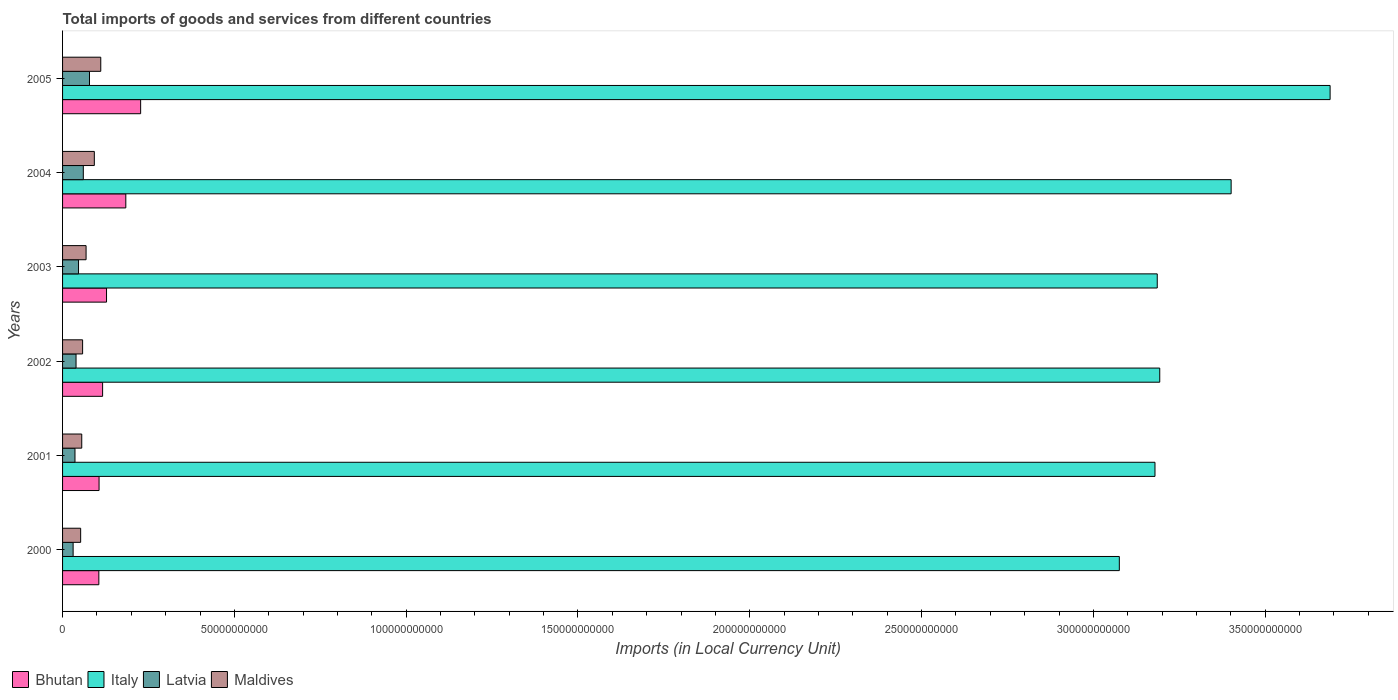How many different coloured bars are there?
Provide a short and direct response. 4. How many groups of bars are there?
Make the answer very short. 6. Are the number of bars on each tick of the Y-axis equal?
Your response must be concise. Yes. How many bars are there on the 2nd tick from the top?
Offer a very short reply. 4. What is the label of the 1st group of bars from the top?
Ensure brevity in your answer.  2005. In how many cases, is the number of bars for a given year not equal to the number of legend labels?
Provide a short and direct response. 0. What is the Amount of goods and services imports in Italy in 2001?
Provide a short and direct response. 3.18e+11. Across all years, what is the maximum Amount of goods and services imports in Maldives?
Keep it short and to the point. 1.11e+1. Across all years, what is the minimum Amount of goods and services imports in Bhutan?
Ensure brevity in your answer.  1.06e+1. What is the total Amount of goods and services imports in Latvia in the graph?
Your answer should be compact. 2.91e+1. What is the difference between the Amount of goods and services imports in Maldives in 2001 and that in 2003?
Your answer should be compact. -1.26e+09. What is the difference between the Amount of goods and services imports in Latvia in 2001 and the Amount of goods and services imports in Maldives in 2003?
Provide a succinct answer. -3.23e+09. What is the average Amount of goods and services imports in Bhutan per year?
Your answer should be compact. 1.45e+1. In the year 2003, what is the difference between the Amount of goods and services imports in Maldives and Amount of goods and services imports in Latvia?
Give a very brief answer. 2.19e+09. What is the ratio of the Amount of goods and services imports in Bhutan in 2003 to that in 2004?
Provide a short and direct response. 0.7. Is the Amount of goods and services imports in Maldives in 2002 less than that in 2005?
Your answer should be compact. Yes. What is the difference between the highest and the second highest Amount of goods and services imports in Bhutan?
Provide a succinct answer. 4.32e+09. What is the difference between the highest and the lowest Amount of goods and services imports in Bhutan?
Make the answer very short. 1.22e+1. Is the sum of the Amount of goods and services imports in Bhutan in 2002 and 2003 greater than the maximum Amount of goods and services imports in Maldives across all years?
Give a very brief answer. Yes. Is it the case that in every year, the sum of the Amount of goods and services imports in Bhutan and Amount of goods and services imports in Latvia is greater than the sum of Amount of goods and services imports in Maldives and Amount of goods and services imports in Italy?
Provide a succinct answer. Yes. What does the 3rd bar from the top in 2005 represents?
Ensure brevity in your answer.  Italy. What does the 2nd bar from the bottom in 2005 represents?
Provide a short and direct response. Italy. How many bars are there?
Provide a succinct answer. 24. How many years are there in the graph?
Keep it short and to the point. 6. What is the difference between two consecutive major ticks on the X-axis?
Your response must be concise. 5.00e+1. Are the values on the major ticks of X-axis written in scientific E-notation?
Your answer should be compact. No. Does the graph contain any zero values?
Offer a terse response. No. Does the graph contain grids?
Your answer should be compact. No. Where does the legend appear in the graph?
Provide a short and direct response. Bottom left. How many legend labels are there?
Give a very brief answer. 4. What is the title of the graph?
Your response must be concise. Total imports of goods and services from different countries. What is the label or title of the X-axis?
Ensure brevity in your answer.  Imports (in Local Currency Unit). What is the label or title of the Y-axis?
Provide a short and direct response. Years. What is the Imports (in Local Currency Unit) in Bhutan in 2000?
Your answer should be compact. 1.06e+1. What is the Imports (in Local Currency Unit) of Italy in 2000?
Offer a very short reply. 3.08e+11. What is the Imports (in Local Currency Unit) in Latvia in 2000?
Make the answer very short. 3.07e+09. What is the Imports (in Local Currency Unit) in Maldives in 2000?
Give a very brief answer. 5.26e+09. What is the Imports (in Local Currency Unit) of Bhutan in 2001?
Your response must be concise. 1.06e+1. What is the Imports (in Local Currency Unit) of Italy in 2001?
Provide a short and direct response. 3.18e+11. What is the Imports (in Local Currency Unit) in Latvia in 2001?
Your answer should be very brief. 3.61e+09. What is the Imports (in Local Currency Unit) of Maldives in 2001?
Provide a succinct answer. 5.58e+09. What is the Imports (in Local Currency Unit) in Bhutan in 2002?
Offer a terse response. 1.17e+1. What is the Imports (in Local Currency Unit) of Italy in 2002?
Provide a short and direct response. 3.19e+11. What is the Imports (in Local Currency Unit) in Latvia in 2002?
Your answer should be compact. 3.92e+09. What is the Imports (in Local Currency Unit) of Maldives in 2002?
Give a very brief answer. 5.84e+09. What is the Imports (in Local Currency Unit) in Bhutan in 2003?
Your response must be concise. 1.28e+1. What is the Imports (in Local Currency Unit) of Italy in 2003?
Your response must be concise. 3.19e+11. What is the Imports (in Local Currency Unit) of Latvia in 2003?
Provide a short and direct response. 4.65e+09. What is the Imports (in Local Currency Unit) in Maldives in 2003?
Provide a short and direct response. 6.84e+09. What is the Imports (in Local Currency Unit) of Bhutan in 2004?
Your answer should be compact. 1.84e+1. What is the Imports (in Local Currency Unit) in Italy in 2004?
Keep it short and to the point. 3.40e+11. What is the Imports (in Local Currency Unit) in Latvia in 2004?
Your answer should be very brief. 6.04e+09. What is the Imports (in Local Currency Unit) in Maldives in 2004?
Provide a succinct answer. 9.24e+09. What is the Imports (in Local Currency Unit) of Bhutan in 2005?
Offer a terse response. 2.27e+1. What is the Imports (in Local Currency Unit) in Italy in 2005?
Offer a very short reply. 3.69e+11. What is the Imports (in Local Currency Unit) in Latvia in 2005?
Your response must be concise. 7.84e+09. What is the Imports (in Local Currency Unit) of Maldives in 2005?
Provide a short and direct response. 1.11e+1. Across all years, what is the maximum Imports (in Local Currency Unit) of Bhutan?
Offer a very short reply. 2.27e+1. Across all years, what is the maximum Imports (in Local Currency Unit) in Italy?
Offer a very short reply. 3.69e+11. Across all years, what is the maximum Imports (in Local Currency Unit) in Latvia?
Keep it short and to the point. 7.84e+09. Across all years, what is the maximum Imports (in Local Currency Unit) in Maldives?
Make the answer very short. 1.11e+1. Across all years, what is the minimum Imports (in Local Currency Unit) in Bhutan?
Keep it short and to the point. 1.06e+1. Across all years, what is the minimum Imports (in Local Currency Unit) in Italy?
Keep it short and to the point. 3.08e+11. Across all years, what is the minimum Imports (in Local Currency Unit) of Latvia?
Your answer should be very brief. 3.07e+09. Across all years, what is the minimum Imports (in Local Currency Unit) in Maldives?
Your answer should be very brief. 5.26e+09. What is the total Imports (in Local Currency Unit) in Bhutan in the graph?
Ensure brevity in your answer.  8.68e+1. What is the total Imports (in Local Currency Unit) of Italy in the graph?
Your answer should be very brief. 1.97e+12. What is the total Imports (in Local Currency Unit) of Latvia in the graph?
Provide a succinct answer. 2.91e+1. What is the total Imports (in Local Currency Unit) in Maldives in the graph?
Your answer should be compact. 4.39e+1. What is the difference between the Imports (in Local Currency Unit) of Bhutan in 2000 and that in 2001?
Provide a short and direct response. -6.62e+07. What is the difference between the Imports (in Local Currency Unit) in Italy in 2000 and that in 2001?
Offer a very short reply. -1.04e+1. What is the difference between the Imports (in Local Currency Unit) in Latvia in 2000 and that in 2001?
Your answer should be compact. -5.40e+08. What is the difference between the Imports (in Local Currency Unit) of Maldives in 2000 and that in 2001?
Provide a succinct answer. -3.19e+08. What is the difference between the Imports (in Local Currency Unit) of Bhutan in 2000 and that in 2002?
Offer a very short reply. -1.10e+09. What is the difference between the Imports (in Local Currency Unit) of Italy in 2000 and that in 2002?
Make the answer very short. -1.18e+1. What is the difference between the Imports (in Local Currency Unit) in Latvia in 2000 and that in 2002?
Make the answer very short. -8.49e+08. What is the difference between the Imports (in Local Currency Unit) of Maldives in 2000 and that in 2002?
Offer a terse response. -5.72e+08. What is the difference between the Imports (in Local Currency Unit) in Bhutan in 2000 and that in 2003?
Offer a very short reply. -2.24e+09. What is the difference between the Imports (in Local Currency Unit) in Italy in 2000 and that in 2003?
Your answer should be compact. -1.10e+1. What is the difference between the Imports (in Local Currency Unit) in Latvia in 2000 and that in 2003?
Make the answer very short. -1.57e+09. What is the difference between the Imports (in Local Currency Unit) in Maldives in 2000 and that in 2003?
Provide a succinct answer. -1.58e+09. What is the difference between the Imports (in Local Currency Unit) in Bhutan in 2000 and that in 2004?
Your answer should be compact. -7.85e+09. What is the difference between the Imports (in Local Currency Unit) in Italy in 2000 and that in 2004?
Keep it short and to the point. -3.25e+1. What is the difference between the Imports (in Local Currency Unit) in Latvia in 2000 and that in 2004?
Your answer should be very brief. -2.96e+09. What is the difference between the Imports (in Local Currency Unit) in Maldives in 2000 and that in 2004?
Your answer should be very brief. -3.98e+09. What is the difference between the Imports (in Local Currency Unit) in Bhutan in 2000 and that in 2005?
Ensure brevity in your answer.  -1.22e+1. What is the difference between the Imports (in Local Currency Unit) in Italy in 2000 and that in 2005?
Give a very brief answer. -6.13e+1. What is the difference between the Imports (in Local Currency Unit) in Latvia in 2000 and that in 2005?
Make the answer very short. -4.77e+09. What is the difference between the Imports (in Local Currency Unit) of Maldives in 2000 and that in 2005?
Keep it short and to the point. -5.85e+09. What is the difference between the Imports (in Local Currency Unit) of Bhutan in 2001 and that in 2002?
Make the answer very short. -1.03e+09. What is the difference between the Imports (in Local Currency Unit) of Italy in 2001 and that in 2002?
Keep it short and to the point. -1.38e+09. What is the difference between the Imports (in Local Currency Unit) of Latvia in 2001 and that in 2002?
Offer a terse response. -3.09e+08. What is the difference between the Imports (in Local Currency Unit) of Maldives in 2001 and that in 2002?
Keep it short and to the point. -2.53e+08. What is the difference between the Imports (in Local Currency Unit) of Bhutan in 2001 and that in 2003?
Your answer should be compact. -2.17e+09. What is the difference between the Imports (in Local Currency Unit) of Italy in 2001 and that in 2003?
Provide a succinct answer. -6.60e+08. What is the difference between the Imports (in Local Currency Unit) of Latvia in 2001 and that in 2003?
Make the answer very short. -1.03e+09. What is the difference between the Imports (in Local Currency Unit) of Maldives in 2001 and that in 2003?
Provide a short and direct response. -1.26e+09. What is the difference between the Imports (in Local Currency Unit) in Bhutan in 2001 and that in 2004?
Provide a short and direct response. -7.79e+09. What is the difference between the Imports (in Local Currency Unit) in Italy in 2001 and that in 2004?
Ensure brevity in your answer.  -2.22e+1. What is the difference between the Imports (in Local Currency Unit) of Latvia in 2001 and that in 2004?
Offer a very short reply. -2.42e+09. What is the difference between the Imports (in Local Currency Unit) in Maldives in 2001 and that in 2004?
Keep it short and to the point. -3.66e+09. What is the difference between the Imports (in Local Currency Unit) of Bhutan in 2001 and that in 2005?
Your answer should be compact. -1.21e+1. What is the difference between the Imports (in Local Currency Unit) of Italy in 2001 and that in 2005?
Offer a very short reply. -5.10e+1. What is the difference between the Imports (in Local Currency Unit) of Latvia in 2001 and that in 2005?
Ensure brevity in your answer.  -4.23e+09. What is the difference between the Imports (in Local Currency Unit) of Maldives in 2001 and that in 2005?
Keep it short and to the point. -5.53e+09. What is the difference between the Imports (in Local Currency Unit) in Bhutan in 2002 and that in 2003?
Your answer should be compact. -1.14e+09. What is the difference between the Imports (in Local Currency Unit) of Italy in 2002 and that in 2003?
Give a very brief answer. 7.24e+08. What is the difference between the Imports (in Local Currency Unit) of Latvia in 2002 and that in 2003?
Ensure brevity in your answer.  -7.26e+08. What is the difference between the Imports (in Local Currency Unit) in Maldives in 2002 and that in 2003?
Give a very brief answer. -1.01e+09. What is the difference between the Imports (in Local Currency Unit) in Bhutan in 2002 and that in 2004?
Make the answer very short. -6.75e+09. What is the difference between the Imports (in Local Currency Unit) in Italy in 2002 and that in 2004?
Keep it short and to the point. -2.08e+1. What is the difference between the Imports (in Local Currency Unit) of Latvia in 2002 and that in 2004?
Your answer should be very brief. -2.11e+09. What is the difference between the Imports (in Local Currency Unit) of Maldives in 2002 and that in 2004?
Keep it short and to the point. -3.41e+09. What is the difference between the Imports (in Local Currency Unit) of Bhutan in 2002 and that in 2005?
Provide a succinct answer. -1.11e+1. What is the difference between the Imports (in Local Currency Unit) in Italy in 2002 and that in 2005?
Keep it short and to the point. -4.96e+1. What is the difference between the Imports (in Local Currency Unit) in Latvia in 2002 and that in 2005?
Make the answer very short. -3.92e+09. What is the difference between the Imports (in Local Currency Unit) in Maldives in 2002 and that in 2005?
Keep it short and to the point. -5.28e+09. What is the difference between the Imports (in Local Currency Unit) in Bhutan in 2003 and that in 2004?
Your answer should be compact. -5.61e+09. What is the difference between the Imports (in Local Currency Unit) in Italy in 2003 and that in 2004?
Your answer should be very brief. -2.15e+1. What is the difference between the Imports (in Local Currency Unit) in Latvia in 2003 and that in 2004?
Offer a very short reply. -1.39e+09. What is the difference between the Imports (in Local Currency Unit) in Maldives in 2003 and that in 2004?
Make the answer very short. -2.40e+09. What is the difference between the Imports (in Local Currency Unit) of Bhutan in 2003 and that in 2005?
Give a very brief answer. -9.93e+09. What is the difference between the Imports (in Local Currency Unit) of Italy in 2003 and that in 2005?
Provide a short and direct response. -5.03e+1. What is the difference between the Imports (in Local Currency Unit) of Latvia in 2003 and that in 2005?
Make the answer very short. -3.19e+09. What is the difference between the Imports (in Local Currency Unit) of Maldives in 2003 and that in 2005?
Provide a succinct answer. -4.28e+09. What is the difference between the Imports (in Local Currency Unit) in Bhutan in 2004 and that in 2005?
Offer a terse response. -4.32e+09. What is the difference between the Imports (in Local Currency Unit) of Italy in 2004 and that in 2005?
Your response must be concise. -2.88e+1. What is the difference between the Imports (in Local Currency Unit) of Latvia in 2004 and that in 2005?
Your response must be concise. -1.80e+09. What is the difference between the Imports (in Local Currency Unit) of Maldives in 2004 and that in 2005?
Your answer should be compact. -1.87e+09. What is the difference between the Imports (in Local Currency Unit) of Bhutan in 2000 and the Imports (in Local Currency Unit) of Italy in 2001?
Your answer should be very brief. -3.07e+11. What is the difference between the Imports (in Local Currency Unit) of Bhutan in 2000 and the Imports (in Local Currency Unit) of Latvia in 2001?
Give a very brief answer. 6.94e+09. What is the difference between the Imports (in Local Currency Unit) in Bhutan in 2000 and the Imports (in Local Currency Unit) in Maldives in 2001?
Your answer should be compact. 4.97e+09. What is the difference between the Imports (in Local Currency Unit) in Italy in 2000 and the Imports (in Local Currency Unit) in Latvia in 2001?
Offer a very short reply. 3.04e+11. What is the difference between the Imports (in Local Currency Unit) in Italy in 2000 and the Imports (in Local Currency Unit) in Maldives in 2001?
Your answer should be very brief. 3.02e+11. What is the difference between the Imports (in Local Currency Unit) in Latvia in 2000 and the Imports (in Local Currency Unit) in Maldives in 2001?
Keep it short and to the point. -2.51e+09. What is the difference between the Imports (in Local Currency Unit) of Bhutan in 2000 and the Imports (in Local Currency Unit) of Italy in 2002?
Provide a short and direct response. -3.09e+11. What is the difference between the Imports (in Local Currency Unit) of Bhutan in 2000 and the Imports (in Local Currency Unit) of Latvia in 2002?
Make the answer very short. 6.63e+09. What is the difference between the Imports (in Local Currency Unit) of Bhutan in 2000 and the Imports (in Local Currency Unit) of Maldives in 2002?
Offer a terse response. 4.72e+09. What is the difference between the Imports (in Local Currency Unit) in Italy in 2000 and the Imports (in Local Currency Unit) in Latvia in 2002?
Give a very brief answer. 3.04e+11. What is the difference between the Imports (in Local Currency Unit) in Italy in 2000 and the Imports (in Local Currency Unit) in Maldives in 2002?
Give a very brief answer. 3.02e+11. What is the difference between the Imports (in Local Currency Unit) in Latvia in 2000 and the Imports (in Local Currency Unit) in Maldives in 2002?
Your response must be concise. -2.76e+09. What is the difference between the Imports (in Local Currency Unit) of Bhutan in 2000 and the Imports (in Local Currency Unit) of Italy in 2003?
Your response must be concise. -3.08e+11. What is the difference between the Imports (in Local Currency Unit) in Bhutan in 2000 and the Imports (in Local Currency Unit) in Latvia in 2003?
Offer a terse response. 5.91e+09. What is the difference between the Imports (in Local Currency Unit) of Bhutan in 2000 and the Imports (in Local Currency Unit) of Maldives in 2003?
Offer a very short reply. 3.71e+09. What is the difference between the Imports (in Local Currency Unit) of Italy in 2000 and the Imports (in Local Currency Unit) of Latvia in 2003?
Your answer should be compact. 3.03e+11. What is the difference between the Imports (in Local Currency Unit) in Italy in 2000 and the Imports (in Local Currency Unit) in Maldives in 2003?
Provide a succinct answer. 3.01e+11. What is the difference between the Imports (in Local Currency Unit) of Latvia in 2000 and the Imports (in Local Currency Unit) of Maldives in 2003?
Offer a very short reply. -3.77e+09. What is the difference between the Imports (in Local Currency Unit) in Bhutan in 2000 and the Imports (in Local Currency Unit) in Italy in 2004?
Provide a succinct answer. -3.30e+11. What is the difference between the Imports (in Local Currency Unit) of Bhutan in 2000 and the Imports (in Local Currency Unit) of Latvia in 2004?
Your answer should be very brief. 4.52e+09. What is the difference between the Imports (in Local Currency Unit) in Bhutan in 2000 and the Imports (in Local Currency Unit) in Maldives in 2004?
Ensure brevity in your answer.  1.31e+09. What is the difference between the Imports (in Local Currency Unit) in Italy in 2000 and the Imports (in Local Currency Unit) in Latvia in 2004?
Your response must be concise. 3.02e+11. What is the difference between the Imports (in Local Currency Unit) of Italy in 2000 and the Imports (in Local Currency Unit) of Maldives in 2004?
Give a very brief answer. 2.98e+11. What is the difference between the Imports (in Local Currency Unit) in Latvia in 2000 and the Imports (in Local Currency Unit) in Maldives in 2004?
Your answer should be compact. -6.17e+09. What is the difference between the Imports (in Local Currency Unit) in Bhutan in 2000 and the Imports (in Local Currency Unit) in Italy in 2005?
Offer a very short reply. -3.58e+11. What is the difference between the Imports (in Local Currency Unit) of Bhutan in 2000 and the Imports (in Local Currency Unit) of Latvia in 2005?
Your response must be concise. 2.72e+09. What is the difference between the Imports (in Local Currency Unit) of Bhutan in 2000 and the Imports (in Local Currency Unit) of Maldives in 2005?
Offer a very short reply. -5.61e+08. What is the difference between the Imports (in Local Currency Unit) of Italy in 2000 and the Imports (in Local Currency Unit) of Latvia in 2005?
Make the answer very short. 3.00e+11. What is the difference between the Imports (in Local Currency Unit) in Italy in 2000 and the Imports (in Local Currency Unit) in Maldives in 2005?
Keep it short and to the point. 2.96e+11. What is the difference between the Imports (in Local Currency Unit) of Latvia in 2000 and the Imports (in Local Currency Unit) of Maldives in 2005?
Provide a succinct answer. -8.04e+09. What is the difference between the Imports (in Local Currency Unit) of Bhutan in 2001 and the Imports (in Local Currency Unit) of Italy in 2002?
Keep it short and to the point. -3.09e+11. What is the difference between the Imports (in Local Currency Unit) of Bhutan in 2001 and the Imports (in Local Currency Unit) of Latvia in 2002?
Offer a terse response. 6.70e+09. What is the difference between the Imports (in Local Currency Unit) in Bhutan in 2001 and the Imports (in Local Currency Unit) in Maldives in 2002?
Make the answer very short. 4.79e+09. What is the difference between the Imports (in Local Currency Unit) of Italy in 2001 and the Imports (in Local Currency Unit) of Latvia in 2002?
Your answer should be compact. 3.14e+11. What is the difference between the Imports (in Local Currency Unit) of Italy in 2001 and the Imports (in Local Currency Unit) of Maldives in 2002?
Ensure brevity in your answer.  3.12e+11. What is the difference between the Imports (in Local Currency Unit) of Latvia in 2001 and the Imports (in Local Currency Unit) of Maldives in 2002?
Make the answer very short. -2.22e+09. What is the difference between the Imports (in Local Currency Unit) in Bhutan in 2001 and the Imports (in Local Currency Unit) in Italy in 2003?
Provide a short and direct response. -3.08e+11. What is the difference between the Imports (in Local Currency Unit) in Bhutan in 2001 and the Imports (in Local Currency Unit) in Latvia in 2003?
Your answer should be compact. 5.97e+09. What is the difference between the Imports (in Local Currency Unit) of Bhutan in 2001 and the Imports (in Local Currency Unit) of Maldives in 2003?
Your answer should be compact. 3.78e+09. What is the difference between the Imports (in Local Currency Unit) in Italy in 2001 and the Imports (in Local Currency Unit) in Latvia in 2003?
Your answer should be very brief. 3.13e+11. What is the difference between the Imports (in Local Currency Unit) of Italy in 2001 and the Imports (in Local Currency Unit) of Maldives in 2003?
Offer a very short reply. 3.11e+11. What is the difference between the Imports (in Local Currency Unit) in Latvia in 2001 and the Imports (in Local Currency Unit) in Maldives in 2003?
Your answer should be compact. -3.23e+09. What is the difference between the Imports (in Local Currency Unit) in Bhutan in 2001 and the Imports (in Local Currency Unit) in Italy in 2004?
Keep it short and to the point. -3.29e+11. What is the difference between the Imports (in Local Currency Unit) of Bhutan in 2001 and the Imports (in Local Currency Unit) of Latvia in 2004?
Provide a succinct answer. 4.59e+09. What is the difference between the Imports (in Local Currency Unit) in Bhutan in 2001 and the Imports (in Local Currency Unit) in Maldives in 2004?
Your answer should be very brief. 1.38e+09. What is the difference between the Imports (in Local Currency Unit) of Italy in 2001 and the Imports (in Local Currency Unit) of Latvia in 2004?
Offer a very short reply. 3.12e+11. What is the difference between the Imports (in Local Currency Unit) in Italy in 2001 and the Imports (in Local Currency Unit) in Maldives in 2004?
Make the answer very short. 3.09e+11. What is the difference between the Imports (in Local Currency Unit) in Latvia in 2001 and the Imports (in Local Currency Unit) in Maldives in 2004?
Your response must be concise. -5.63e+09. What is the difference between the Imports (in Local Currency Unit) of Bhutan in 2001 and the Imports (in Local Currency Unit) of Italy in 2005?
Make the answer very short. -3.58e+11. What is the difference between the Imports (in Local Currency Unit) in Bhutan in 2001 and the Imports (in Local Currency Unit) in Latvia in 2005?
Offer a very short reply. 2.78e+09. What is the difference between the Imports (in Local Currency Unit) in Bhutan in 2001 and the Imports (in Local Currency Unit) in Maldives in 2005?
Offer a terse response. -4.95e+08. What is the difference between the Imports (in Local Currency Unit) in Italy in 2001 and the Imports (in Local Currency Unit) in Latvia in 2005?
Give a very brief answer. 3.10e+11. What is the difference between the Imports (in Local Currency Unit) in Italy in 2001 and the Imports (in Local Currency Unit) in Maldives in 2005?
Give a very brief answer. 3.07e+11. What is the difference between the Imports (in Local Currency Unit) of Latvia in 2001 and the Imports (in Local Currency Unit) of Maldives in 2005?
Your response must be concise. -7.50e+09. What is the difference between the Imports (in Local Currency Unit) of Bhutan in 2002 and the Imports (in Local Currency Unit) of Italy in 2003?
Provide a short and direct response. -3.07e+11. What is the difference between the Imports (in Local Currency Unit) in Bhutan in 2002 and the Imports (in Local Currency Unit) in Latvia in 2003?
Keep it short and to the point. 7.01e+09. What is the difference between the Imports (in Local Currency Unit) of Bhutan in 2002 and the Imports (in Local Currency Unit) of Maldives in 2003?
Give a very brief answer. 4.81e+09. What is the difference between the Imports (in Local Currency Unit) in Italy in 2002 and the Imports (in Local Currency Unit) in Latvia in 2003?
Your response must be concise. 3.15e+11. What is the difference between the Imports (in Local Currency Unit) of Italy in 2002 and the Imports (in Local Currency Unit) of Maldives in 2003?
Provide a succinct answer. 3.12e+11. What is the difference between the Imports (in Local Currency Unit) of Latvia in 2002 and the Imports (in Local Currency Unit) of Maldives in 2003?
Offer a terse response. -2.92e+09. What is the difference between the Imports (in Local Currency Unit) of Bhutan in 2002 and the Imports (in Local Currency Unit) of Italy in 2004?
Keep it short and to the point. -3.28e+11. What is the difference between the Imports (in Local Currency Unit) of Bhutan in 2002 and the Imports (in Local Currency Unit) of Latvia in 2004?
Keep it short and to the point. 5.62e+09. What is the difference between the Imports (in Local Currency Unit) in Bhutan in 2002 and the Imports (in Local Currency Unit) in Maldives in 2004?
Your response must be concise. 2.41e+09. What is the difference between the Imports (in Local Currency Unit) in Italy in 2002 and the Imports (in Local Currency Unit) in Latvia in 2004?
Make the answer very short. 3.13e+11. What is the difference between the Imports (in Local Currency Unit) of Italy in 2002 and the Imports (in Local Currency Unit) of Maldives in 2004?
Your answer should be compact. 3.10e+11. What is the difference between the Imports (in Local Currency Unit) in Latvia in 2002 and the Imports (in Local Currency Unit) in Maldives in 2004?
Provide a succinct answer. -5.32e+09. What is the difference between the Imports (in Local Currency Unit) of Bhutan in 2002 and the Imports (in Local Currency Unit) of Italy in 2005?
Offer a very short reply. -3.57e+11. What is the difference between the Imports (in Local Currency Unit) in Bhutan in 2002 and the Imports (in Local Currency Unit) in Latvia in 2005?
Your answer should be compact. 3.81e+09. What is the difference between the Imports (in Local Currency Unit) in Bhutan in 2002 and the Imports (in Local Currency Unit) in Maldives in 2005?
Keep it short and to the point. 5.37e+08. What is the difference between the Imports (in Local Currency Unit) in Italy in 2002 and the Imports (in Local Currency Unit) in Latvia in 2005?
Keep it short and to the point. 3.11e+11. What is the difference between the Imports (in Local Currency Unit) of Italy in 2002 and the Imports (in Local Currency Unit) of Maldives in 2005?
Offer a terse response. 3.08e+11. What is the difference between the Imports (in Local Currency Unit) of Latvia in 2002 and the Imports (in Local Currency Unit) of Maldives in 2005?
Make the answer very short. -7.19e+09. What is the difference between the Imports (in Local Currency Unit) in Bhutan in 2003 and the Imports (in Local Currency Unit) in Italy in 2004?
Provide a short and direct response. -3.27e+11. What is the difference between the Imports (in Local Currency Unit) in Bhutan in 2003 and the Imports (in Local Currency Unit) in Latvia in 2004?
Provide a short and direct response. 6.76e+09. What is the difference between the Imports (in Local Currency Unit) in Bhutan in 2003 and the Imports (in Local Currency Unit) in Maldives in 2004?
Give a very brief answer. 3.55e+09. What is the difference between the Imports (in Local Currency Unit) of Italy in 2003 and the Imports (in Local Currency Unit) of Latvia in 2004?
Provide a short and direct response. 3.13e+11. What is the difference between the Imports (in Local Currency Unit) of Italy in 2003 and the Imports (in Local Currency Unit) of Maldives in 2004?
Your response must be concise. 3.09e+11. What is the difference between the Imports (in Local Currency Unit) in Latvia in 2003 and the Imports (in Local Currency Unit) in Maldives in 2004?
Ensure brevity in your answer.  -4.60e+09. What is the difference between the Imports (in Local Currency Unit) of Bhutan in 2003 and the Imports (in Local Currency Unit) of Italy in 2005?
Your response must be concise. -3.56e+11. What is the difference between the Imports (in Local Currency Unit) in Bhutan in 2003 and the Imports (in Local Currency Unit) in Latvia in 2005?
Provide a succinct answer. 4.96e+09. What is the difference between the Imports (in Local Currency Unit) in Bhutan in 2003 and the Imports (in Local Currency Unit) in Maldives in 2005?
Ensure brevity in your answer.  1.68e+09. What is the difference between the Imports (in Local Currency Unit) of Italy in 2003 and the Imports (in Local Currency Unit) of Latvia in 2005?
Ensure brevity in your answer.  3.11e+11. What is the difference between the Imports (in Local Currency Unit) of Italy in 2003 and the Imports (in Local Currency Unit) of Maldives in 2005?
Offer a terse response. 3.07e+11. What is the difference between the Imports (in Local Currency Unit) in Latvia in 2003 and the Imports (in Local Currency Unit) in Maldives in 2005?
Your answer should be very brief. -6.47e+09. What is the difference between the Imports (in Local Currency Unit) in Bhutan in 2004 and the Imports (in Local Currency Unit) in Italy in 2005?
Make the answer very short. -3.50e+11. What is the difference between the Imports (in Local Currency Unit) in Bhutan in 2004 and the Imports (in Local Currency Unit) in Latvia in 2005?
Offer a very short reply. 1.06e+1. What is the difference between the Imports (in Local Currency Unit) of Bhutan in 2004 and the Imports (in Local Currency Unit) of Maldives in 2005?
Offer a terse response. 7.29e+09. What is the difference between the Imports (in Local Currency Unit) in Italy in 2004 and the Imports (in Local Currency Unit) in Latvia in 2005?
Your answer should be very brief. 3.32e+11. What is the difference between the Imports (in Local Currency Unit) in Italy in 2004 and the Imports (in Local Currency Unit) in Maldives in 2005?
Your answer should be compact. 3.29e+11. What is the difference between the Imports (in Local Currency Unit) of Latvia in 2004 and the Imports (in Local Currency Unit) of Maldives in 2005?
Give a very brief answer. -5.08e+09. What is the average Imports (in Local Currency Unit) of Bhutan per year?
Provide a short and direct response. 1.45e+1. What is the average Imports (in Local Currency Unit) in Italy per year?
Ensure brevity in your answer.  3.29e+11. What is the average Imports (in Local Currency Unit) of Latvia per year?
Offer a very short reply. 4.86e+09. What is the average Imports (in Local Currency Unit) of Maldives per year?
Provide a short and direct response. 7.31e+09. In the year 2000, what is the difference between the Imports (in Local Currency Unit) of Bhutan and Imports (in Local Currency Unit) of Italy?
Keep it short and to the point. -2.97e+11. In the year 2000, what is the difference between the Imports (in Local Currency Unit) in Bhutan and Imports (in Local Currency Unit) in Latvia?
Offer a terse response. 7.48e+09. In the year 2000, what is the difference between the Imports (in Local Currency Unit) of Bhutan and Imports (in Local Currency Unit) of Maldives?
Your answer should be very brief. 5.29e+09. In the year 2000, what is the difference between the Imports (in Local Currency Unit) in Italy and Imports (in Local Currency Unit) in Latvia?
Your answer should be compact. 3.04e+11. In the year 2000, what is the difference between the Imports (in Local Currency Unit) of Italy and Imports (in Local Currency Unit) of Maldives?
Offer a terse response. 3.02e+11. In the year 2000, what is the difference between the Imports (in Local Currency Unit) in Latvia and Imports (in Local Currency Unit) in Maldives?
Your response must be concise. -2.19e+09. In the year 2001, what is the difference between the Imports (in Local Currency Unit) in Bhutan and Imports (in Local Currency Unit) in Italy?
Your answer should be very brief. -3.07e+11. In the year 2001, what is the difference between the Imports (in Local Currency Unit) in Bhutan and Imports (in Local Currency Unit) in Latvia?
Offer a terse response. 7.01e+09. In the year 2001, what is the difference between the Imports (in Local Currency Unit) in Bhutan and Imports (in Local Currency Unit) in Maldives?
Keep it short and to the point. 5.04e+09. In the year 2001, what is the difference between the Imports (in Local Currency Unit) of Italy and Imports (in Local Currency Unit) of Latvia?
Provide a short and direct response. 3.14e+11. In the year 2001, what is the difference between the Imports (in Local Currency Unit) of Italy and Imports (in Local Currency Unit) of Maldives?
Make the answer very short. 3.12e+11. In the year 2001, what is the difference between the Imports (in Local Currency Unit) in Latvia and Imports (in Local Currency Unit) in Maldives?
Offer a terse response. -1.97e+09. In the year 2002, what is the difference between the Imports (in Local Currency Unit) of Bhutan and Imports (in Local Currency Unit) of Italy?
Give a very brief answer. -3.08e+11. In the year 2002, what is the difference between the Imports (in Local Currency Unit) of Bhutan and Imports (in Local Currency Unit) of Latvia?
Give a very brief answer. 7.73e+09. In the year 2002, what is the difference between the Imports (in Local Currency Unit) in Bhutan and Imports (in Local Currency Unit) in Maldives?
Your answer should be very brief. 5.82e+09. In the year 2002, what is the difference between the Imports (in Local Currency Unit) in Italy and Imports (in Local Currency Unit) in Latvia?
Offer a very short reply. 3.15e+11. In the year 2002, what is the difference between the Imports (in Local Currency Unit) of Italy and Imports (in Local Currency Unit) of Maldives?
Provide a succinct answer. 3.13e+11. In the year 2002, what is the difference between the Imports (in Local Currency Unit) in Latvia and Imports (in Local Currency Unit) in Maldives?
Keep it short and to the point. -1.91e+09. In the year 2003, what is the difference between the Imports (in Local Currency Unit) in Bhutan and Imports (in Local Currency Unit) in Italy?
Make the answer very short. -3.06e+11. In the year 2003, what is the difference between the Imports (in Local Currency Unit) of Bhutan and Imports (in Local Currency Unit) of Latvia?
Ensure brevity in your answer.  8.15e+09. In the year 2003, what is the difference between the Imports (in Local Currency Unit) in Bhutan and Imports (in Local Currency Unit) in Maldives?
Provide a short and direct response. 5.95e+09. In the year 2003, what is the difference between the Imports (in Local Currency Unit) of Italy and Imports (in Local Currency Unit) of Latvia?
Your response must be concise. 3.14e+11. In the year 2003, what is the difference between the Imports (in Local Currency Unit) in Italy and Imports (in Local Currency Unit) in Maldives?
Make the answer very short. 3.12e+11. In the year 2003, what is the difference between the Imports (in Local Currency Unit) of Latvia and Imports (in Local Currency Unit) of Maldives?
Offer a very short reply. -2.19e+09. In the year 2004, what is the difference between the Imports (in Local Currency Unit) in Bhutan and Imports (in Local Currency Unit) in Italy?
Your answer should be compact. -3.22e+11. In the year 2004, what is the difference between the Imports (in Local Currency Unit) of Bhutan and Imports (in Local Currency Unit) of Latvia?
Keep it short and to the point. 1.24e+1. In the year 2004, what is the difference between the Imports (in Local Currency Unit) in Bhutan and Imports (in Local Currency Unit) in Maldives?
Ensure brevity in your answer.  9.16e+09. In the year 2004, what is the difference between the Imports (in Local Currency Unit) in Italy and Imports (in Local Currency Unit) in Latvia?
Provide a succinct answer. 3.34e+11. In the year 2004, what is the difference between the Imports (in Local Currency Unit) of Italy and Imports (in Local Currency Unit) of Maldives?
Make the answer very short. 3.31e+11. In the year 2004, what is the difference between the Imports (in Local Currency Unit) in Latvia and Imports (in Local Currency Unit) in Maldives?
Give a very brief answer. -3.21e+09. In the year 2005, what is the difference between the Imports (in Local Currency Unit) of Bhutan and Imports (in Local Currency Unit) of Italy?
Provide a short and direct response. -3.46e+11. In the year 2005, what is the difference between the Imports (in Local Currency Unit) of Bhutan and Imports (in Local Currency Unit) of Latvia?
Your response must be concise. 1.49e+1. In the year 2005, what is the difference between the Imports (in Local Currency Unit) in Bhutan and Imports (in Local Currency Unit) in Maldives?
Offer a terse response. 1.16e+1. In the year 2005, what is the difference between the Imports (in Local Currency Unit) of Italy and Imports (in Local Currency Unit) of Latvia?
Your response must be concise. 3.61e+11. In the year 2005, what is the difference between the Imports (in Local Currency Unit) in Italy and Imports (in Local Currency Unit) in Maldives?
Keep it short and to the point. 3.58e+11. In the year 2005, what is the difference between the Imports (in Local Currency Unit) in Latvia and Imports (in Local Currency Unit) in Maldives?
Keep it short and to the point. -3.28e+09. What is the ratio of the Imports (in Local Currency Unit) of Bhutan in 2000 to that in 2001?
Your response must be concise. 0.99. What is the ratio of the Imports (in Local Currency Unit) in Italy in 2000 to that in 2001?
Offer a very short reply. 0.97. What is the ratio of the Imports (in Local Currency Unit) of Latvia in 2000 to that in 2001?
Provide a succinct answer. 0.85. What is the ratio of the Imports (in Local Currency Unit) of Maldives in 2000 to that in 2001?
Your answer should be compact. 0.94. What is the ratio of the Imports (in Local Currency Unit) in Bhutan in 2000 to that in 2002?
Provide a short and direct response. 0.91. What is the ratio of the Imports (in Local Currency Unit) in Italy in 2000 to that in 2002?
Offer a very short reply. 0.96. What is the ratio of the Imports (in Local Currency Unit) of Latvia in 2000 to that in 2002?
Ensure brevity in your answer.  0.78. What is the ratio of the Imports (in Local Currency Unit) of Maldives in 2000 to that in 2002?
Give a very brief answer. 0.9. What is the ratio of the Imports (in Local Currency Unit) in Bhutan in 2000 to that in 2003?
Ensure brevity in your answer.  0.82. What is the ratio of the Imports (in Local Currency Unit) in Italy in 2000 to that in 2003?
Provide a short and direct response. 0.97. What is the ratio of the Imports (in Local Currency Unit) in Latvia in 2000 to that in 2003?
Ensure brevity in your answer.  0.66. What is the ratio of the Imports (in Local Currency Unit) of Maldives in 2000 to that in 2003?
Your response must be concise. 0.77. What is the ratio of the Imports (in Local Currency Unit) of Bhutan in 2000 to that in 2004?
Keep it short and to the point. 0.57. What is the ratio of the Imports (in Local Currency Unit) of Italy in 2000 to that in 2004?
Your answer should be very brief. 0.9. What is the ratio of the Imports (in Local Currency Unit) in Latvia in 2000 to that in 2004?
Your response must be concise. 0.51. What is the ratio of the Imports (in Local Currency Unit) in Maldives in 2000 to that in 2004?
Your answer should be compact. 0.57. What is the ratio of the Imports (in Local Currency Unit) of Bhutan in 2000 to that in 2005?
Your answer should be very brief. 0.46. What is the ratio of the Imports (in Local Currency Unit) of Italy in 2000 to that in 2005?
Your answer should be very brief. 0.83. What is the ratio of the Imports (in Local Currency Unit) in Latvia in 2000 to that in 2005?
Keep it short and to the point. 0.39. What is the ratio of the Imports (in Local Currency Unit) in Maldives in 2000 to that in 2005?
Keep it short and to the point. 0.47. What is the ratio of the Imports (in Local Currency Unit) of Bhutan in 2001 to that in 2002?
Give a very brief answer. 0.91. What is the ratio of the Imports (in Local Currency Unit) in Latvia in 2001 to that in 2002?
Your answer should be compact. 0.92. What is the ratio of the Imports (in Local Currency Unit) of Maldives in 2001 to that in 2002?
Ensure brevity in your answer.  0.96. What is the ratio of the Imports (in Local Currency Unit) in Bhutan in 2001 to that in 2003?
Give a very brief answer. 0.83. What is the ratio of the Imports (in Local Currency Unit) in Italy in 2001 to that in 2003?
Make the answer very short. 1. What is the ratio of the Imports (in Local Currency Unit) of Latvia in 2001 to that in 2003?
Your answer should be compact. 0.78. What is the ratio of the Imports (in Local Currency Unit) of Maldives in 2001 to that in 2003?
Your answer should be very brief. 0.82. What is the ratio of the Imports (in Local Currency Unit) in Bhutan in 2001 to that in 2004?
Give a very brief answer. 0.58. What is the ratio of the Imports (in Local Currency Unit) in Italy in 2001 to that in 2004?
Your response must be concise. 0.93. What is the ratio of the Imports (in Local Currency Unit) of Latvia in 2001 to that in 2004?
Offer a very short reply. 0.6. What is the ratio of the Imports (in Local Currency Unit) of Maldives in 2001 to that in 2004?
Your answer should be very brief. 0.6. What is the ratio of the Imports (in Local Currency Unit) in Bhutan in 2001 to that in 2005?
Your response must be concise. 0.47. What is the ratio of the Imports (in Local Currency Unit) in Italy in 2001 to that in 2005?
Give a very brief answer. 0.86. What is the ratio of the Imports (in Local Currency Unit) in Latvia in 2001 to that in 2005?
Make the answer very short. 0.46. What is the ratio of the Imports (in Local Currency Unit) of Maldives in 2001 to that in 2005?
Provide a short and direct response. 0.5. What is the ratio of the Imports (in Local Currency Unit) of Bhutan in 2002 to that in 2003?
Make the answer very short. 0.91. What is the ratio of the Imports (in Local Currency Unit) in Latvia in 2002 to that in 2003?
Your response must be concise. 0.84. What is the ratio of the Imports (in Local Currency Unit) in Maldives in 2002 to that in 2003?
Provide a succinct answer. 0.85. What is the ratio of the Imports (in Local Currency Unit) of Bhutan in 2002 to that in 2004?
Ensure brevity in your answer.  0.63. What is the ratio of the Imports (in Local Currency Unit) of Italy in 2002 to that in 2004?
Your response must be concise. 0.94. What is the ratio of the Imports (in Local Currency Unit) of Latvia in 2002 to that in 2004?
Keep it short and to the point. 0.65. What is the ratio of the Imports (in Local Currency Unit) of Maldives in 2002 to that in 2004?
Provide a short and direct response. 0.63. What is the ratio of the Imports (in Local Currency Unit) of Bhutan in 2002 to that in 2005?
Your answer should be compact. 0.51. What is the ratio of the Imports (in Local Currency Unit) of Italy in 2002 to that in 2005?
Keep it short and to the point. 0.87. What is the ratio of the Imports (in Local Currency Unit) in Latvia in 2002 to that in 2005?
Give a very brief answer. 0.5. What is the ratio of the Imports (in Local Currency Unit) in Maldives in 2002 to that in 2005?
Offer a very short reply. 0.52. What is the ratio of the Imports (in Local Currency Unit) in Bhutan in 2003 to that in 2004?
Your response must be concise. 0.7. What is the ratio of the Imports (in Local Currency Unit) in Italy in 2003 to that in 2004?
Provide a short and direct response. 0.94. What is the ratio of the Imports (in Local Currency Unit) of Latvia in 2003 to that in 2004?
Keep it short and to the point. 0.77. What is the ratio of the Imports (in Local Currency Unit) in Maldives in 2003 to that in 2004?
Your response must be concise. 0.74. What is the ratio of the Imports (in Local Currency Unit) of Bhutan in 2003 to that in 2005?
Ensure brevity in your answer.  0.56. What is the ratio of the Imports (in Local Currency Unit) in Italy in 2003 to that in 2005?
Offer a very short reply. 0.86. What is the ratio of the Imports (in Local Currency Unit) in Latvia in 2003 to that in 2005?
Offer a terse response. 0.59. What is the ratio of the Imports (in Local Currency Unit) of Maldives in 2003 to that in 2005?
Give a very brief answer. 0.62. What is the ratio of the Imports (in Local Currency Unit) in Bhutan in 2004 to that in 2005?
Your answer should be compact. 0.81. What is the ratio of the Imports (in Local Currency Unit) of Italy in 2004 to that in 2005?
Provide a succinct answer. 0.92. What is the ratio of the Imports (in Local Currency Unit) of Latvia in 2004 to that in 2005?
Make the answer very short. 0.77. What is the ratio of the Imports (in Local Currency Unit) in Maldives in 2004 to that in 2005?
Your answer should be very brief. 0.83. What is the difference between the highest and the second highest Imports (in Local Currency Unit) of Bhutan?
Your response must be concise. 4.32e+09. What is the difference between the highest and the second highest Imports (in Local Currency Unit) of Italy?
Your response must be concise. 2.88e+1. What is the difference between the highest and the second highest Imports (in Local Currency Unit) of Latvia?
Offer a terse response. 1.80e+09. What is the difference between the highest and the second highest Imports (in Local Currency Unit) of Maldives?
Make the answer very short. 1.87e+09. What is the difference between the highest and the lowest Imports (in Local Currency Unit) of Bhutan?
Offer a very short reply. 1.22e+1. What is the difference between the highest and the lowest Imports (in Local Currency Unit) in Italy?
Offer a very short reply. 6.13e+1. What is the difference between the highest and the lowest Imports (in Local Currency Unit) of Latvia?
Your response must be concise. 4.77e+09. What is the difference between the highest and the lowest Imports (in Local Currency Unit) in Maldives?
Provide a succinct answer. 5.85e+09. 